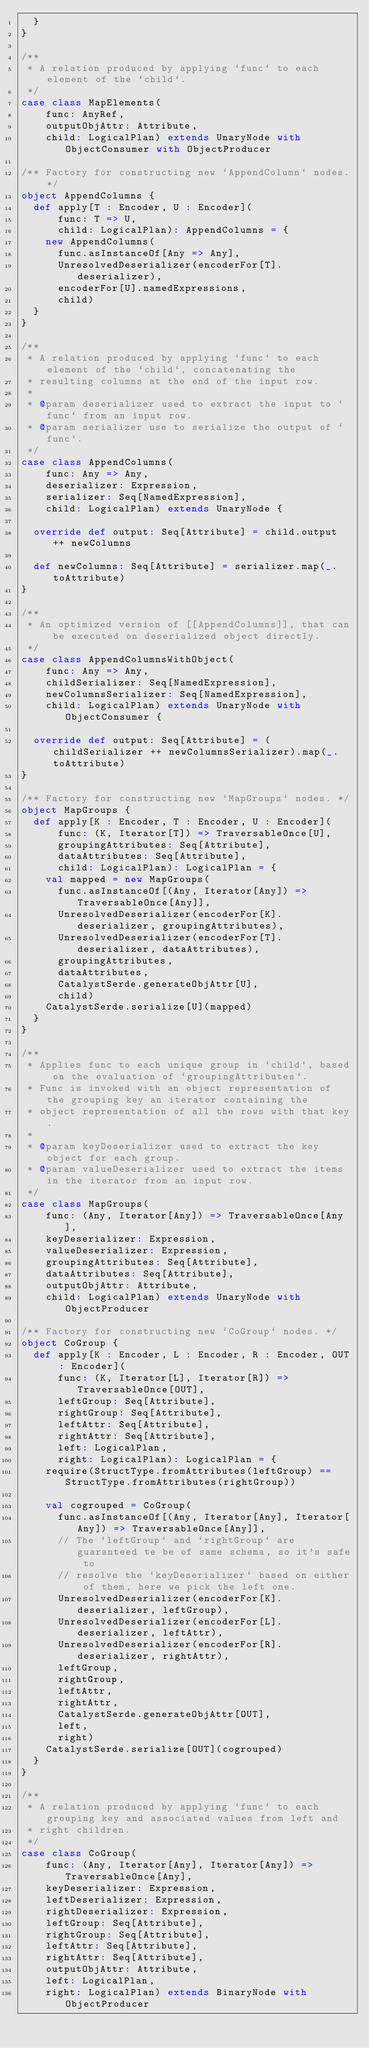<code> <loc_0><loc_0><loc_500><loc_500><_Scala_>  }
}

/**
 * A relation produced by applying `func` to each element of the `child`.
 */
case class MapElements(
    func: AnyRef,
    outputObjAttr: Attribute,
    child: LogicalPlan) extends UnaryNode with ObjectConsumer with ObjectProducer

/** Factory for constructing new `AppendColumn` nodes. */
object AppendColumns {
  def apply[T : Encoder, U : Encoder](
      func: T => U,
      child: LogicalPlan): AppendColumns = {
    new AppendColumns(
      func.asInstanceOf[Any => Any],
      UnresolvedDeserializer(encoderFor[T].deserializer),
      encoderFor[U].namedExpressions,
      child)
  }
}

/**
 * A relation produced by applying `func` to each element of the `child`, concatenating the
 * resulting columns at the end of the input row.
 *
 * @param deserializer used to extract the input to `func` from an input row.
 * @param serializer use to serialize the output of `func`.
 */
case class AppendColumns(
    func: Any => Any,
    deserializer: Expression,
    serializer: Seq[NamedExpression],
    child: LogicalPlan) extends UnaryNode {

  override def output: Seq[Attribute] = child.output ++ newColumns

  def newColumns: Seq[Attribute] = serializer.map(_.toAttribute)
}

/**
 * An optimized version of [[AppendColumns]], that can be executed on deserialized object directly.
 */
case class AppendColumnsWithObject(
    func: Any => Any,
    childSerializer: Seq[NamedExpression],
    newColumnsSerializer: Seq[NamedExpression],
    child: LogicalPlan) extends UnaryNode with ObjectConsumer {

  override def output: Seq[Attribute] = (childSerializer ++ newColumnsSerializer).map(_.toAttribute)
}

/** Factory for constructing new `MapGroups` nodes. */
object MapGroups {
  def apply[K : Encoder, T : Encoder, U : Encoder](
      func: (K, Iterator[T]) => TraversableOnce[U],
      groupingAttributes: Seq[Attribute],
      dataAttributes: Seq[Attribute],
      child: LogicalPlan): LogicalPlan = {
    val mapped = new MapGroups(
      func.asInstanceOf[(Any, Iterator[Any]) => TraversableOnce[Any]],
      UnresolvedDeserializer(encoderFor[K].deserializer, groupingAttributes),
      UnresolvedDeserializer(encoderFor[T].deserializer, dataAttributes),
      groupingAttributes,
      dataAttributes,
      CatalystSerde.generateObjAttr[U],
      child)
    CatalystSerde.serialize[U](mapped)
  }
}

/**
 * Applies func to each unique group in `child`, based on the evaluation of `groupingAttributes`.
 * Func is invoked with an object representation of the grouping key an iterator containing the
 * object representation of all the rows with that key.
 *
 * @param keyDeserializer used to extract the key object for each group.
 * @param valueDeserializer used to extract the items in the iterator from an input row.
 */
case class MapGroups(
    func: (Any, Iterator[Any]) => TraversableOnce[Any],
    keyDeserializer: Expression,
    valueDeserializer: Expression,
    groupingAttributes: Seq[Attribute],
    dataAttributes: Seq[Attribute],
    outputObjAttr: Attribute,
    child: LogicalPlan) extends UnaryNode with ObjectProducer

/** Factory for constructing new `CoGroup` nodes. */
object CoGroup {
  def apply[K : Encoder, L : Encoder, R : Encoder, OUT : Encoder](
      func: (K, Iterator[L], Iterator[R]) => TraversableOnce[OUT],
      leftGroup: Seq[Attribute],
      rightGroup: Seq[Attribute],
      leftAttr: Seq[Attribute],
      rightAttr: Seq[Attribute],
      left: LogicalPlan,
      right: LogicalPlan): LogicalPlan = {
    require(StructType.fromAttributes(leftGroup) == StructType.fromAttributes(rightGroup))

    val cogrouped = CoGroup(
      func.asInstanceOf[(Any, Iterator[Any], Iterator[Any]) => TraversableOnce[Any]],
      // The `leftGroup` and `rightGroup` are guaranteed te be of same schema, so it's safe to
      // resolve the `keyDeserializer` based on either of them, here we pick the left one.
      UnresolvedDeserializer(encoderFor[K].deserializer, leftGroup),
      UnresolvedDeserializer(encoderFor[L].deserializer, leftAttr),
      UnresolvedDeserializer(encoderFor[R].deserializer, rightAttr),
      leftGroup,
      rightGroup,
      leftAttr,
      rightAttr,
      CatalystSerde.generateObjAttr[OUT],
      left,
      right)
    CatalystSerde.serialize[OUT](cogrouped)
  }
}

/**
 * A relation produced by applying `func` to each grouping key and associated values from left and
 * right children.
 */
case class CoGroup(
    func: (Any, Iterator[Any], Iterator[Any]) => TraversableOnce[Any],
    keyDeserializer: Expression,
    leftDeserializer: Expression,
    rightDeserializer: Expression,
    leftGroup: Seq[Attribute],
    rightGroup: Seq[Attribute],
    leftAttr: Seq[Attribute],
    rightAttr: Seq[Attribute],
    outputObjAttr: Attribute,
    left: LogicalPlan,
    right: LogicalPlan) extends BinaryNode with ObjectProducer
</code> 